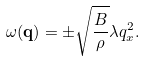<formula> <loc_0><loc_0><loc_500><loc_500>\omega ( { \mathbf q } ) = \pm \sqrt { \frac { B } { \rho } } \lambda q _ { x } ^ { 2 } .</formula> 